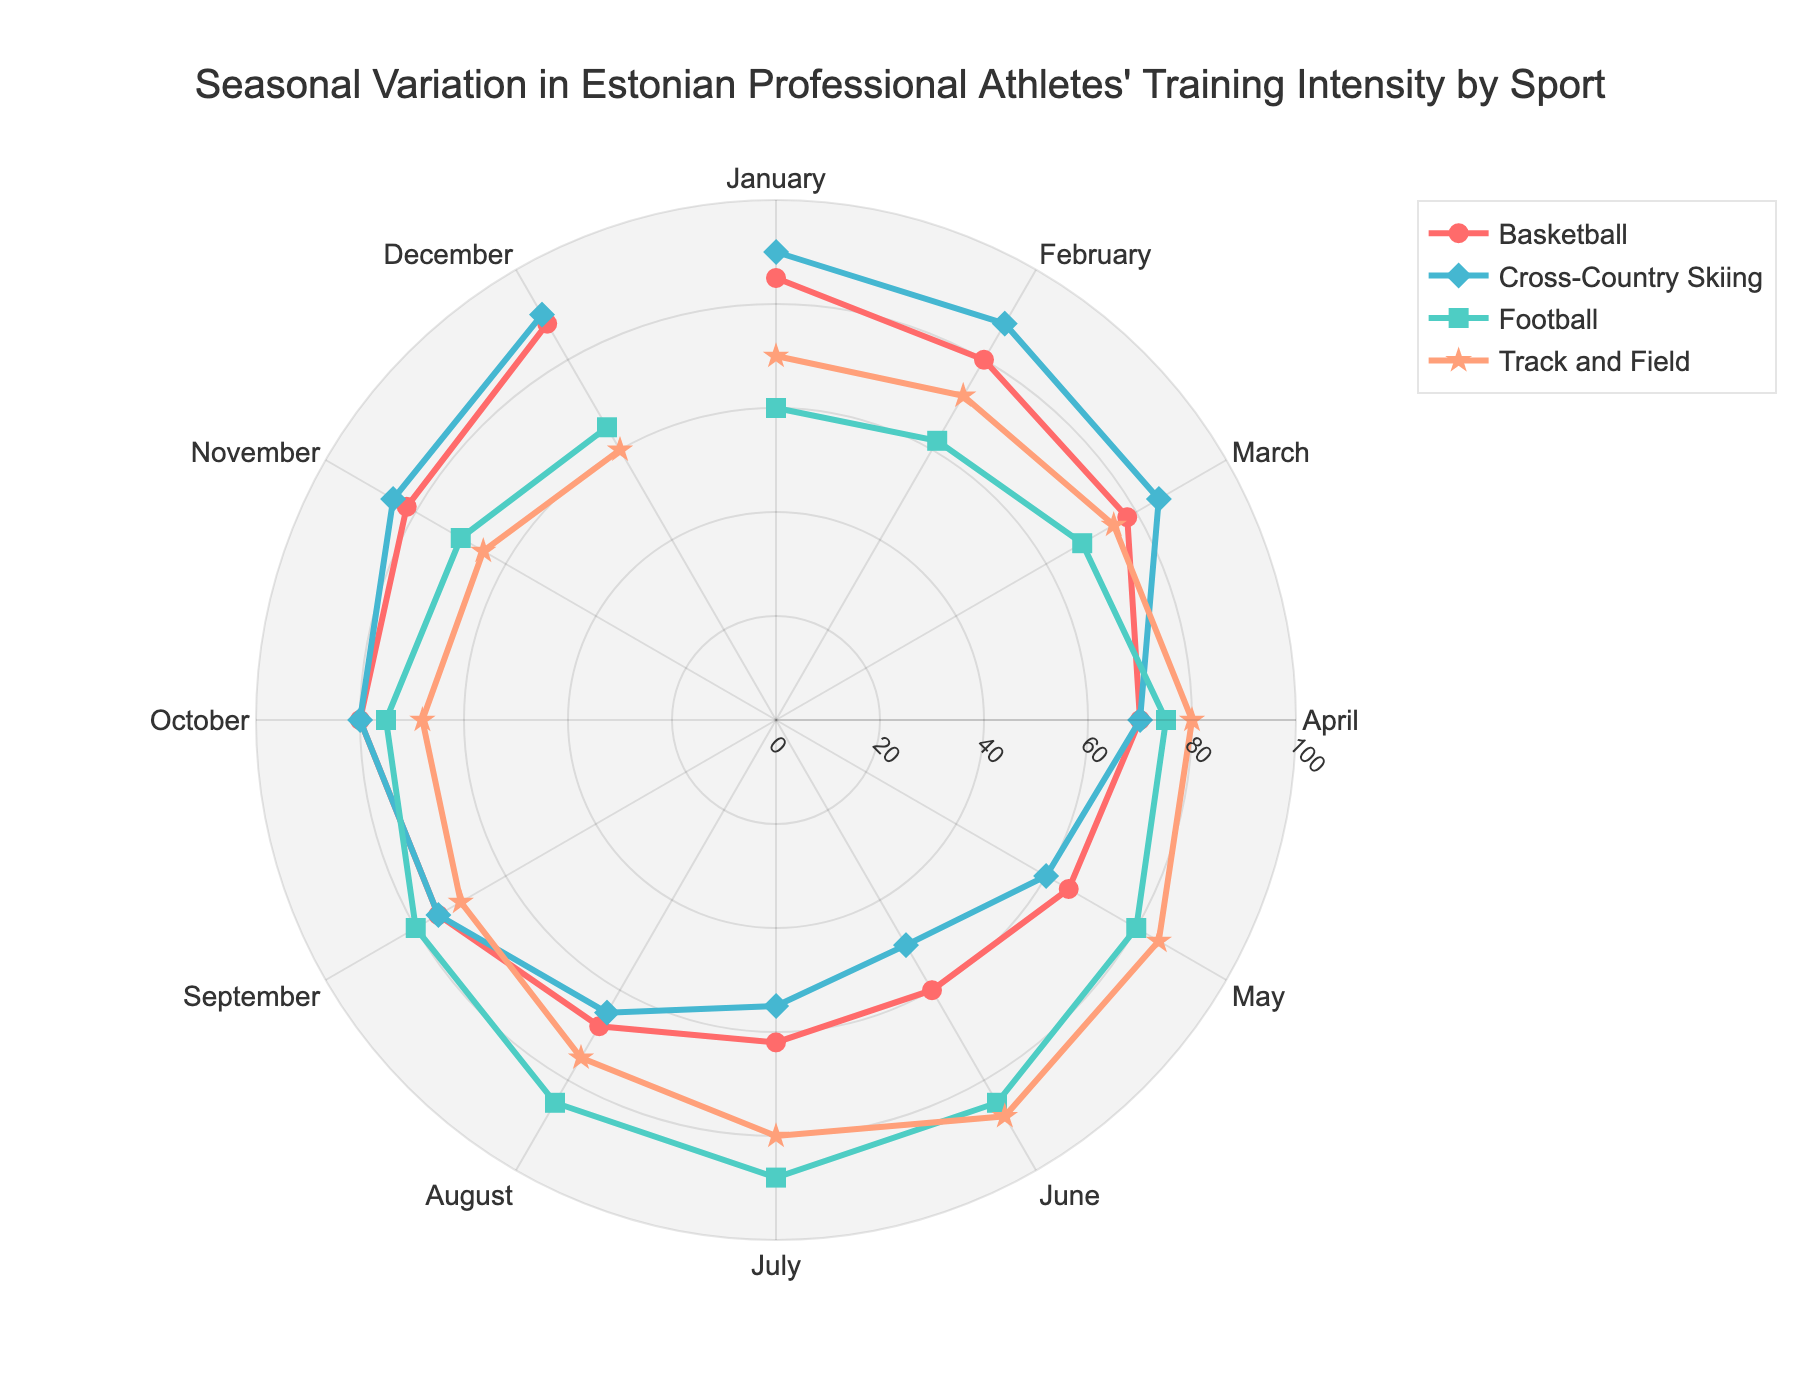What is the highest training intensity for Basketball? The highest training intensity for Basketball can be determined by looking for the maximum value on the radial axis associated with Basketball data points. The highest value is 88 in December.
Answer: 88 Which sport has the highest training intensity in July? The radial coordinate of the July data points for each sport needs to be checked. Football has the highest value with a training intensity of 88.
Answer: Football How does the training intensity for Cross-Country Skiing change from October to December? The training intensity values for Cross-Country Skiing in October, November, and December are 80, 85, and 90 respectively. This shows a steady increase.
Answer: Increases What is the average training intensity for Track and Field from April to June? Summing up the training intensities for Track and Field in April (80), May (85), and June (88), the total is 253. Dividing by 3 gives the average: 253 / 3 = 84.33
Answer: 84.33 Which sport exhibits the most variation in training intensity throughout the year? To determine variation, we can look at the range (difference between highest and lowest training intensities). Cross-Country Skiing ranges from 90 to 50 (a range of 40), which is higher than the range for the other sports.
Answer: Cross-Country Skiing During which month is the training intensity for Football the lowest? The lowest training intensity for Football is observed in January with a value of 60.
Answer: January Compare the training intensity trends of Basketball and Track and Field from January to May. Both sports start with increasing training intensity in January, but Basketball decreases slightly after March while Track and Field keeps increasing until May.
Answer: Track and Field consistently increases What is the difference in training intensity for Cross-Country Skiing between January and July? The training intensity for Cross-Country Skiing in January is 90 and in July it is 55. The difference is 90 - 55 = 35.
Answer: 35 Which sport has the smallest change in training intensity from January to December? The change is evaluated by calculating the difference between January and December values for each sport. Basketball changes by 3 (85 to 88), Football changes by 5 (60 to 65), Cross-Country Skiing remains the same (90), and Track and Field changes by 10 (70 to 60). Cross-Country Skiing shows no change.
Answer: Cross-Country Skiing 